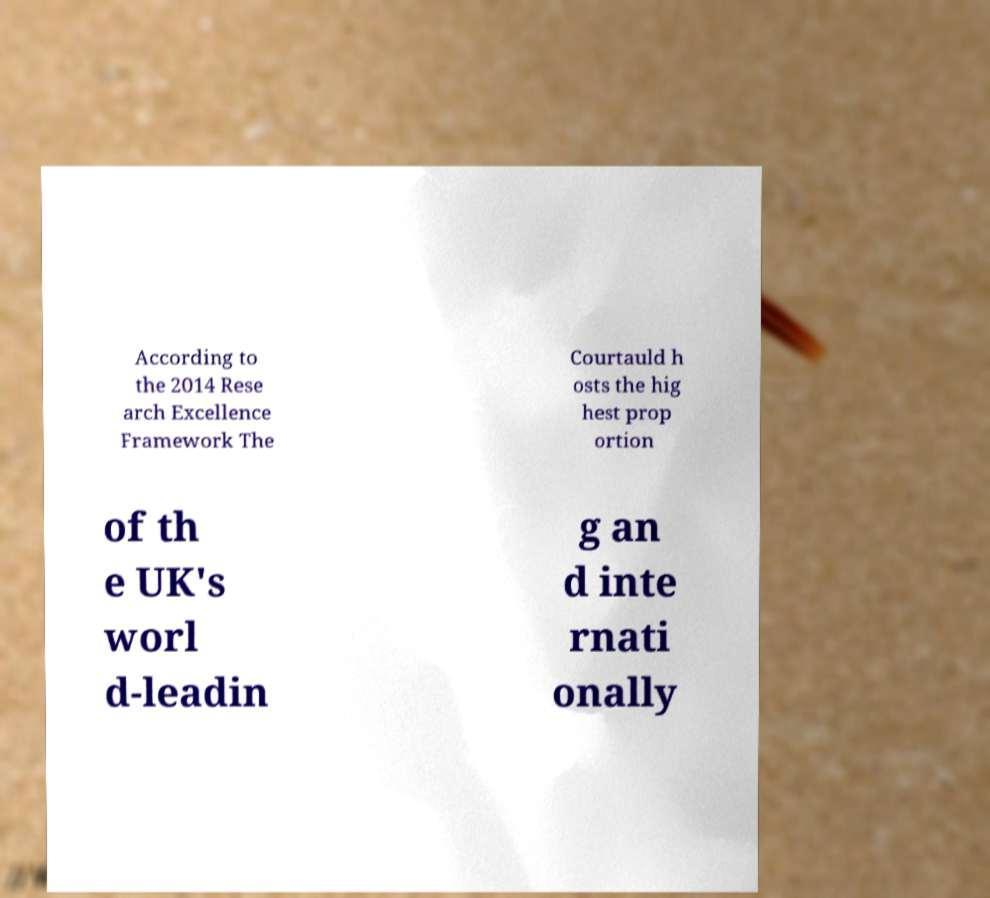Could you extract and type out the text from this image? According to the 2014 Rese arch Excellence Framework The Courtauld h osts the hig hest prop ortion of th e UK's worl d-leadin g an d inte rnati onally 